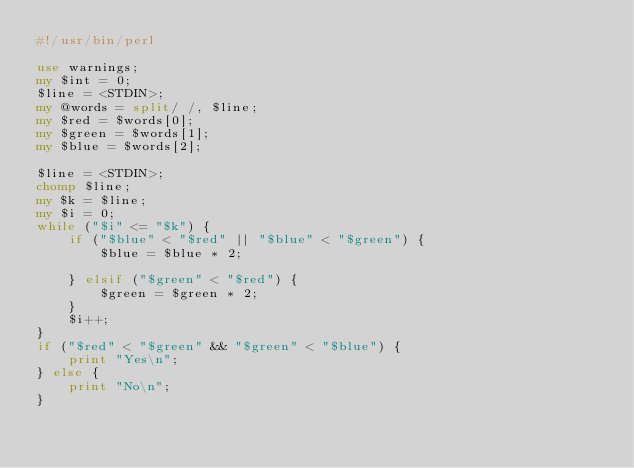<code> <loc_0><loc_0><loc_500><loc_500><_Perl_>#!/usr/bin/perl

use warnings;
my $int = 0;
$line = <STDIN>;
my @words = split/ /, $line; 
my $red = $words[0];
my $green = $words[1];
my $blue = $words[2];

$line = <STDIN>;
chomp $line;
my $k = $line;
my $i = 0;
while ("$i" <= "$k") {
    if ("$blue" < "$red" || "$blue" < "$green") {
        $blue = $blue * 2;
        
    } elsif ("$green" < "$red") {
        $green = $green * 2;
    }
    $i++;
}
if ("$red" < "$green" && "$green" < "$blue") {
    print "Yes\n";
} else {
    print "No\n";
}
</code> 